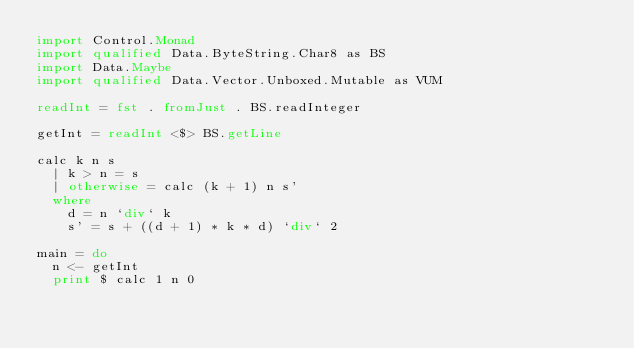<code> <loc_0><loc_0><loc_500><loc_500><_Haskell_>import Control.Monad
import qualified Data.ByteString.Char8 as BS
import Data.Maybe
import qualified Data.Vector.Unboxed.Mutable as VUM

readInt = fst . fromJust . BS.readInteger

getInt = readInt <$> BS.getLine

calc k n s
  | k > n = s
  | otherwise = calc (k + 1) n s'
  where
    d = n `div` k
    s' = s + ((d + 1) * k * d) `div` 2

main = do
  n <- getInt
  print $ calc 1 n 0
</code> 